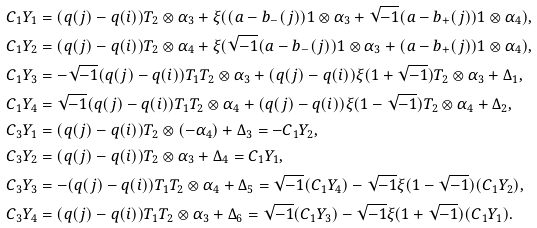Convert formula to latex. <formula><loc_0><loc_0><loc_500><loc_500>C _ { 1 } Y _ { 1 } & = ( q ( j ) - q ( i ) ) T _ { 2 } \otimes \alpha _ { 3 } + \xi ( ( a - b _ { - } ( j ) ) 1 \otimes \alpha _ { 3 } + \sqrt { - 1 } ( a - b _ { + } ( j ) ) 1 \otimes \alpha _ { 4 } ) , \\ C _ { 1 } Y _ { 2 } & = ( q ( j ) - q ( i ) ) T _ { 2 } \otimes \alpha _ { 4 } + \xi ( \sqrt { - 1 } ( a - b _ { - } ( j ) ) 1 \otimes \alpha _ { 3 } + ( a - b _ { + } ( j ) ) 1 \otimes \alpha _ { 4 } ) , \\ C _ { 1 } Y _ { 3 } & = - \sqrt { - 1 } ( q ( j ) - q ( i ) ) T _ { 1 } T _ { 2 } \otimes \alpha _ { 3 } + ( q ( j ) - q ( i ) ) \xi ( 1 + \sqrt { - 1 } ) T _ { 2 } \otimes \alpha _ { 3 } + \Delta _ { 1 } , \\ C _ { 1 } Y _ { 4 } & = \sqrt { - 1 } ( q ( j ) - q ( i ) ) T _ { 1 } T _ { 2 } \otimes \alpha _ { 4 } + ( q ( j ) - q ( i ) ) \xi ( 1 - \sqrt { - 1 } ) T _ { 2 } \otimes \alpha _ { 4 } + \Delta _ { 2 } , \\ C _ { 3 } Y _ { 1 } & = ( q ( j ) - q ( i ) ) T _ { 2 } \otimes ( - \alpha _ { 4 } ) + \Delta _ { 3 } = - C _ { 1 } Y _ { 2 } , \\ C _ { 3 } Y _ { 2 } & = ( q ( j ) - q ( i ) ) T _ { 2 } \otimes \alpha _ { 3 } + \Delta _ { 4 } = C _ { 1 } Y _ { 1 } , \\ C _ { 3 } Y _ { 3 } & = - ( q ( j ) - q ( i ) ) T _ { 1 } T _ { 2 } \otimes \alpha _ { 4 } + \Delta _ { 5 } = \sqrt { - 1 } ( C _ { 1 } Y _ { 4 } ) - \sqrt { - 1 } \xi ( 1 - \sqrt { - 1 } ) ( C _ { 1 } Y _ { 2 } ) , \\ C _ { 3 } Y _ { 4 } & = ( q ( j ) - q ( i ) ) T _ { 1 } T _ { 2 } \otimes \alpha _ { 3 } + \Delta _ { 6 } = \sqrt { - 1 } ( C _ { 1 } Y _ { 3 } ) - \sqrt { - 1 } \xi ( 1 + \sqrt { - 1 } ) ( C _ { 1 } Y _ { 1 } ) .</formula> 